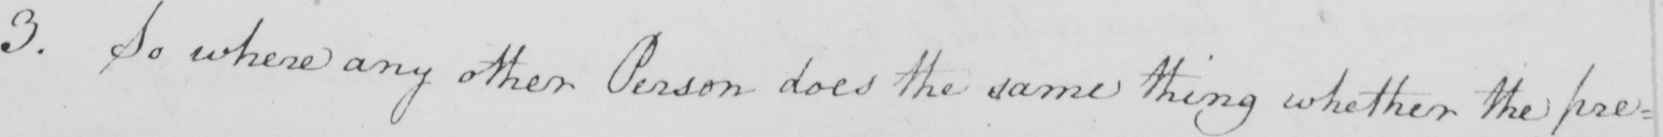What is written in this line of handwriting? 3 . So where any other Person does the same thing whether the pre= 